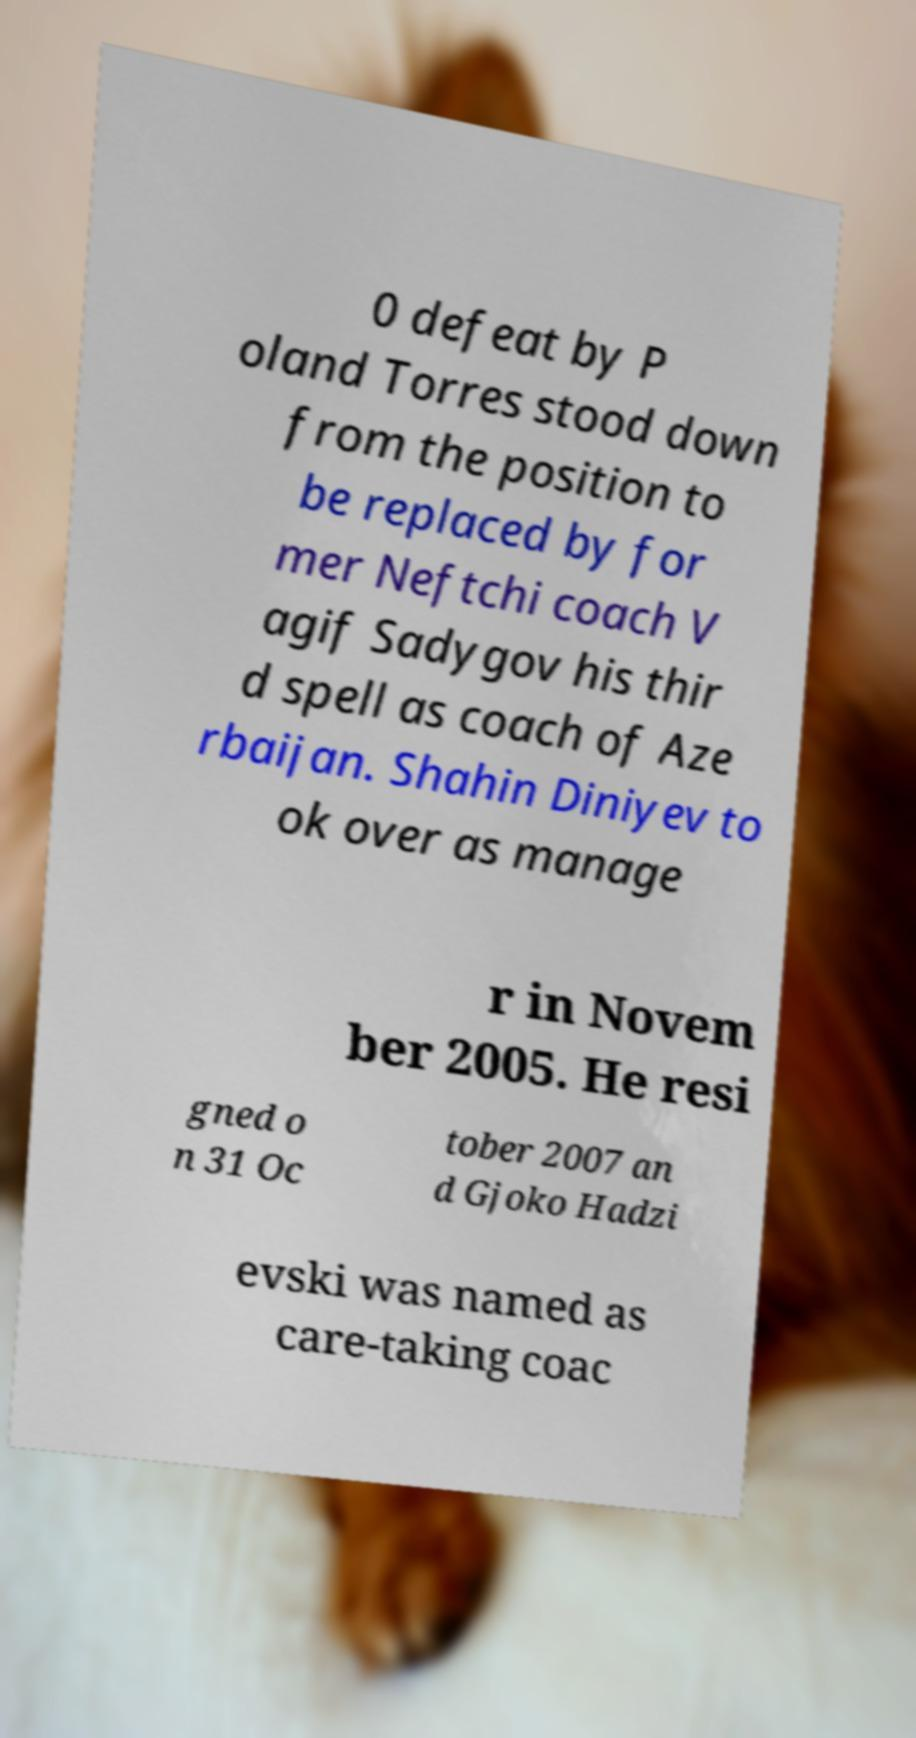Could you assist in decoding the text presented in this image and type it out clearly? 0 defeat by P oland Torres stood down from the position to be replaced by for mer Neftchi coach V agif Sadygov his thir d spell as coach of Aze rbaijan. Shahin Diniyev to ok over as manage r in Novem ber 2005. He resi gned o n 31 Oc tober 2007 an d Gjoko Hadzi evski was named as care-taking coac 